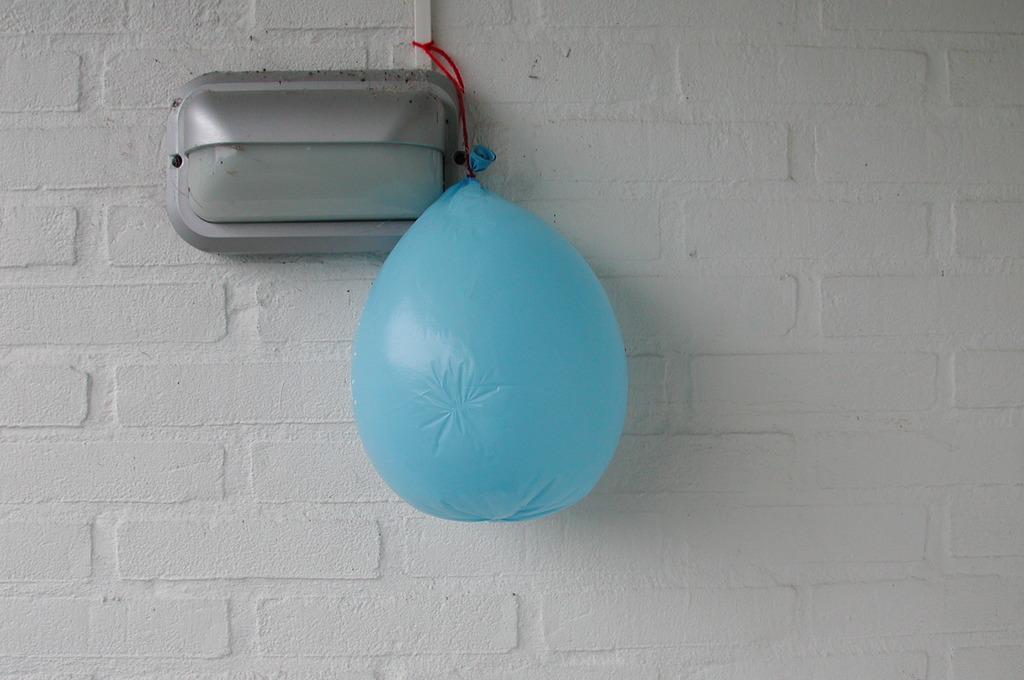Can you describe this image briefly? In this image there is a balloon tied to a pipe and there is a box attached to the wall. 